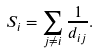<formula> <loc_0><loc_0><loc_500><loc_500>S _ { i } = \sum _ { j \neq i } \frac { 1 } { d _ { i j } } .</formula> 